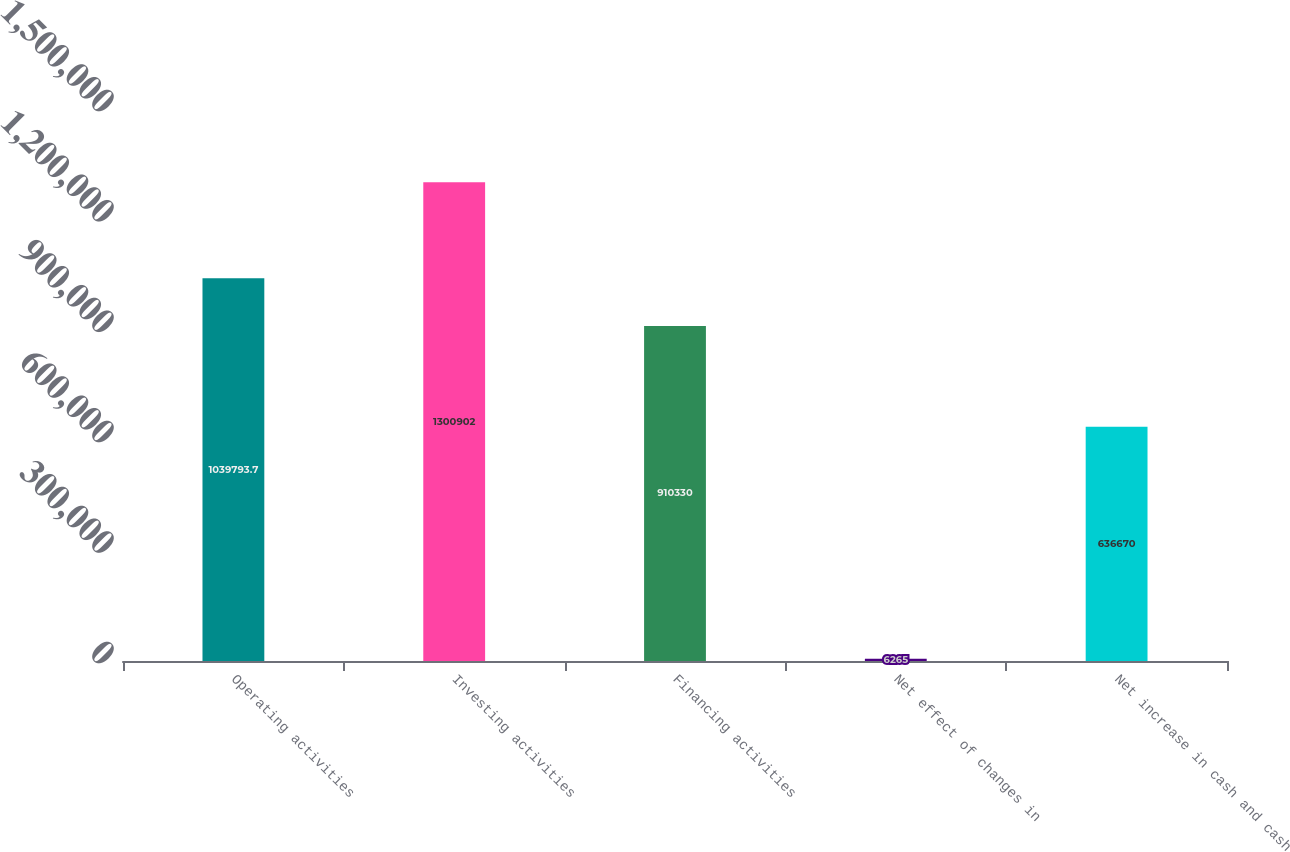Convert chart. <chart><loc_0><loc_0><loc_500><loc_500><bar_chart><fcel>Operating activities<fcel>Investing activities<fcel>Financing activities<fcel>Net effect of changes in<fcel>Net increase in cash and cash<nl><fcel>1.03979e+06<fcel>1.3009e+06<fcel>910330<fcel>6265<fcel>636670<nl></chart> 